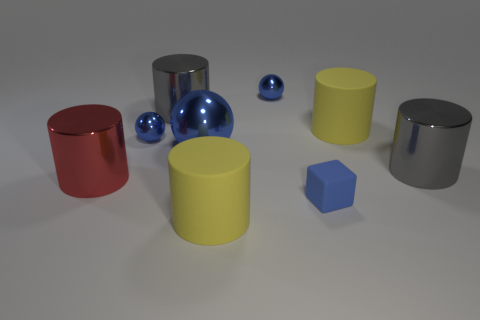How many things are metallic things that are in front of the big metallic ball or tiny shiny things?
Ensure brevity in your answer.  4. Are there more gray shiny objects left of the small blue block than tiny objects that are to the right of the big blue metal object?
Keep it short and to the point. No. Does the tiny block have the same material as the big blue sphere?
Offer a terse response. No. What is the shape of the blue object that is both on the right side of the big blue metal thing and behind the red thing?
Ensure brevity in your answer.  Sphere. There is a large blue thing that is made of the same material as the big red cylinder; what shape is it?
Your response must be concise. Sphere. Are there any blocks?
Keep it short and to the point. Yes. There is a big gray metal cylinder that is in front of the large blue metal object; is there a matte cylinder behind it?
Offer a very short reply. Yes. Are there more yellow rubber blocks than tiny blue spheres?
Your answer should be compact. No. Is the color of the big shiny sphere the same as the small ball that is on the right side of the big blue ball?
Ensure brevity in your answer.  Yes. There is a large object that is in front of the big blue shiny sphere and on the right side of the blue rubber object; what color is it?
Make the answer very short. Gray. 